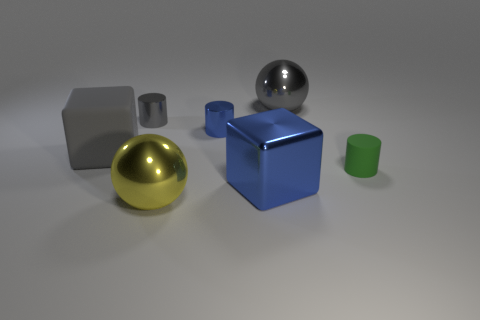Add 2 big matte cubes. How many objects exist? 9 Subtract all metal cylinders. How many cylinders are left? 1 Subtract all blue cylinders. How many cylinders are left? 2 Subtract all purple balls. Subtract all yellow cubes. How many balls are left? 2 Subtract all green cubes. How many red cylinders are left? 0 Subtract all cylinders. Subtract all purple blocks. How many objects are left? 4 Add 2 tiny gray objects. How many tiny gray objects are left? 3 Add 6 tiny green rubber balls. How many tiny green rubber balls exist? 6 Subtract 0 yellow cylinders. How many objects are left? 7 Subtract all cubes. How many objects are left? 5 